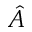<formula> <loc_0><loc_0><loc_500><loc_500>\hat { A }</formula> 